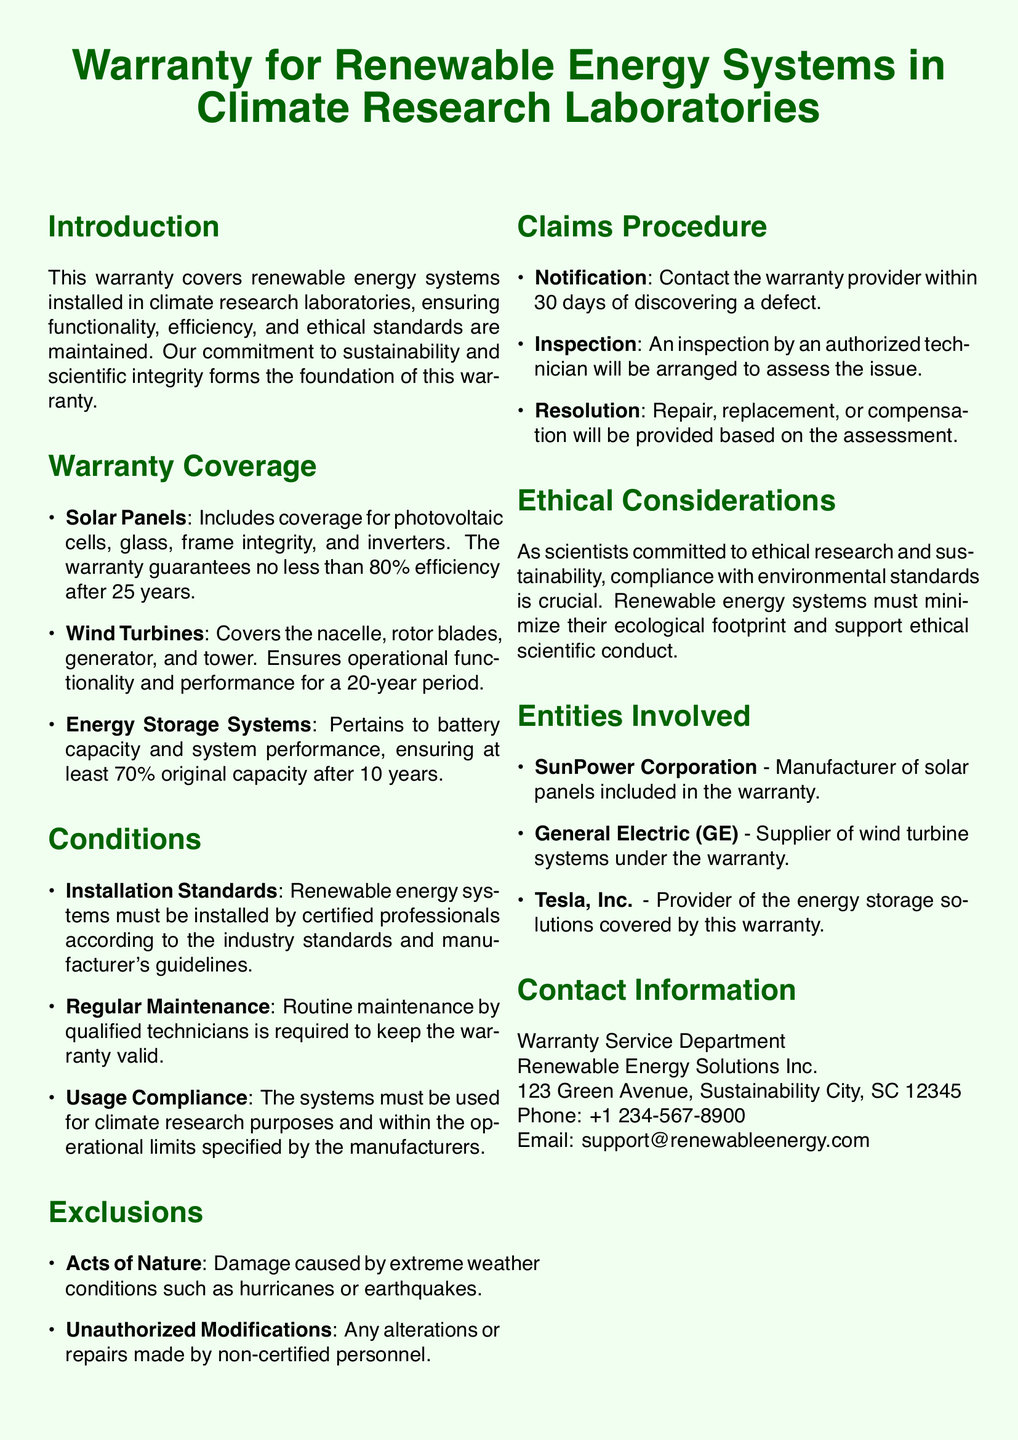What is covered for solar panels? The warranty includes coverage for photovoltaic cells, glass, frame integrity, and inverters.
Answer: Photovoltaic cells, glass, frame integrity, inverters What is the minimum efficiency guarantee for solar panels after 25 years? The document states that the warranty guarantees no less than 80% efficiency after 25 years.
Answer: 80% How long is the coverage period for wind turbines? The warranty ensures operational functionality and performance for a 20-year period for wind turbines.
Answer: 20 years What must be performed for the warranty to remain valid? Routine maintenance by qualified technicians is required to keep the warranty valid.
Answer: Routine maintenance Who manufactures the solar panels included in the warranty? The manufacturer of solar panels mentioned in the warranty is SunPower Corporation.
Answer: SunPower Corporation What is the energy storage system battery capacity guarantee after 10 years? The warranty ensures at least 70% original capacity after 10 years for energy storage systems.
Answer: 70% What action must be taken within 30 days of discovering a defect? The warranty provider must be contacted within 30 days of discovering a defect.
Answer: Contact the warranty provider Which types of damage are excluded from the warranty? Damage caused by extreme weather conditions such as hurricanes or earthquakes is excluded.
Answer: Acts of Nature What is the contact phone number for the warranty service department? The contact phone number provided in the document is +1 234-567-8900.
Answer: +1 234-567-8900 